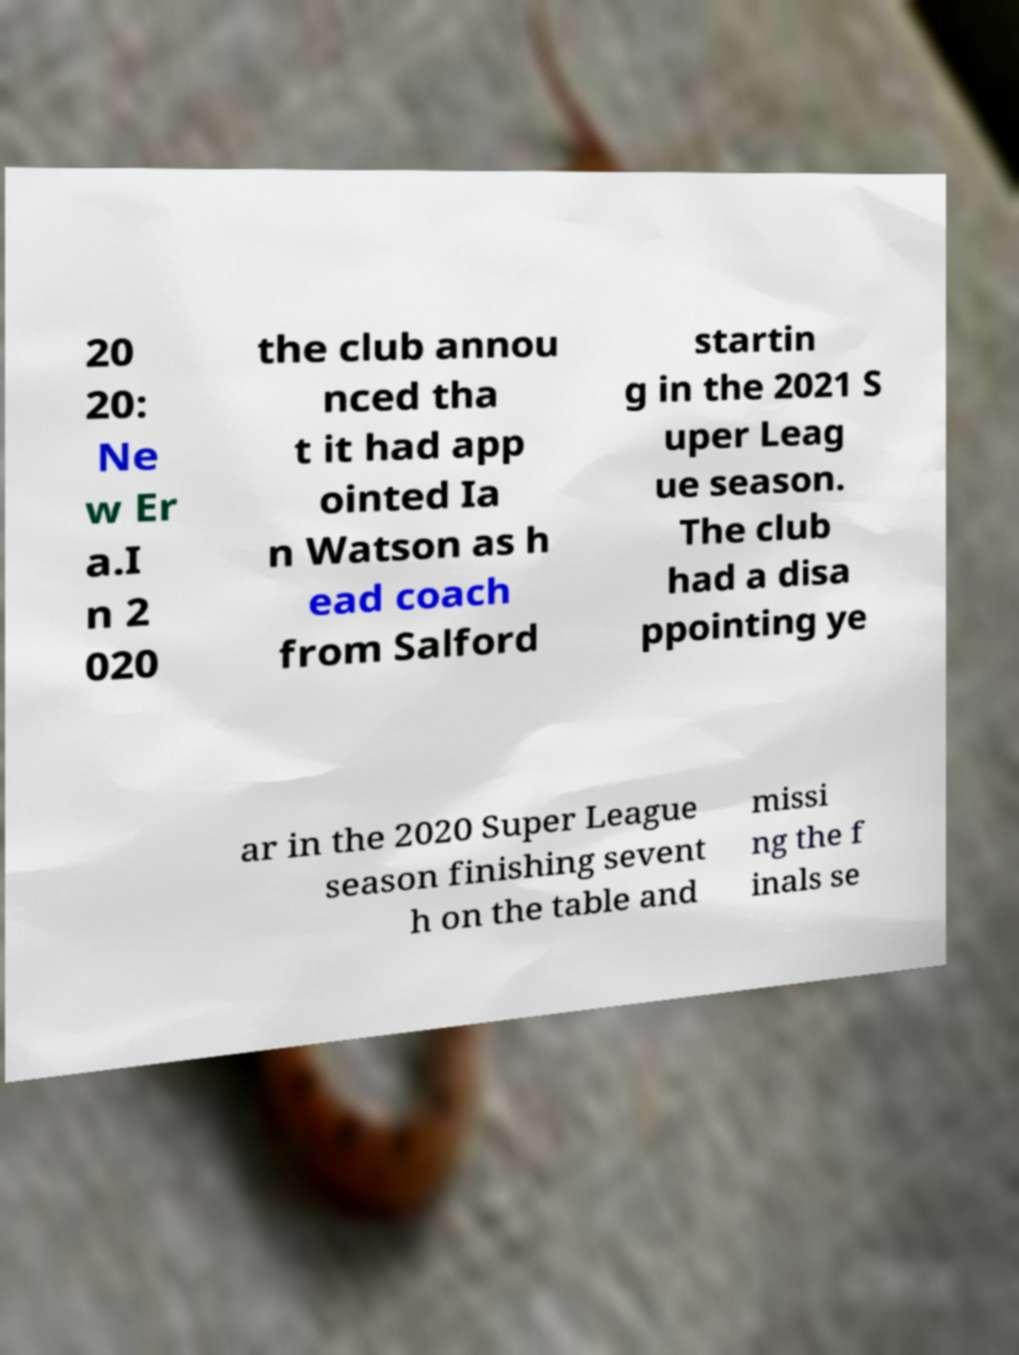For documentation purposes, I need the text within this image transcribed. Could you provide that? 20 20: Ne w Er a.I n 2 020 the club annou nced tha t it had app ointed Ia n Watson as h ead coach from Salford startin g in the 2021 S uper Leag ue season. The club had a disa ppointing ye ar in the 2020 Super League season finishing sevent h on the table and missi ng the f inals se 